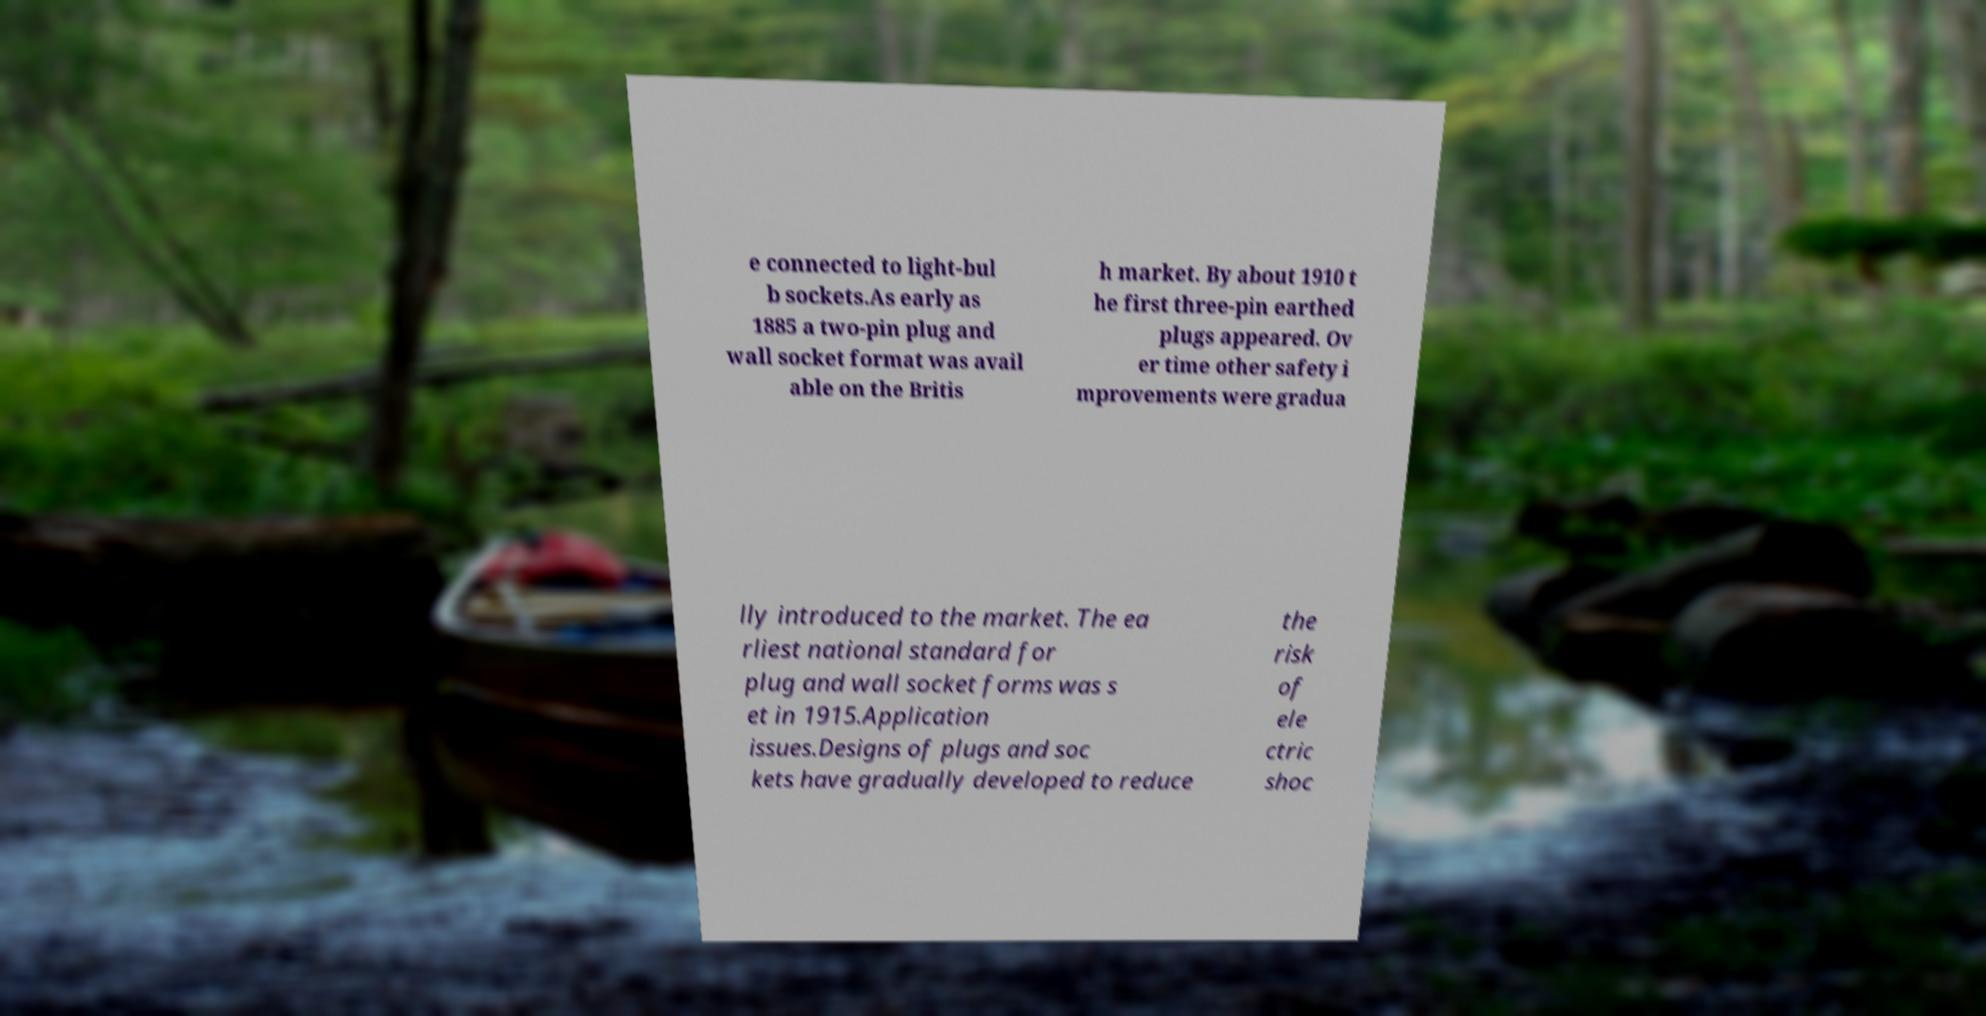Can you accurately transcribe the text from the provided image for me? e connected to light-bul b sockets.As early as 1885 a two-pin plug and wall socket format was avail able on the Britis h market. By about 1910 t he first three-pin earthed plugs appeared. Ov er time other safety i mprovements were gradua lly introduced to the market. The ea rliest national standard for plug and wall socket forms was s et in 1915.Application issues.Designs of plugs and soc kets have gradually developed to reduce the risk of ele ctric shoc 